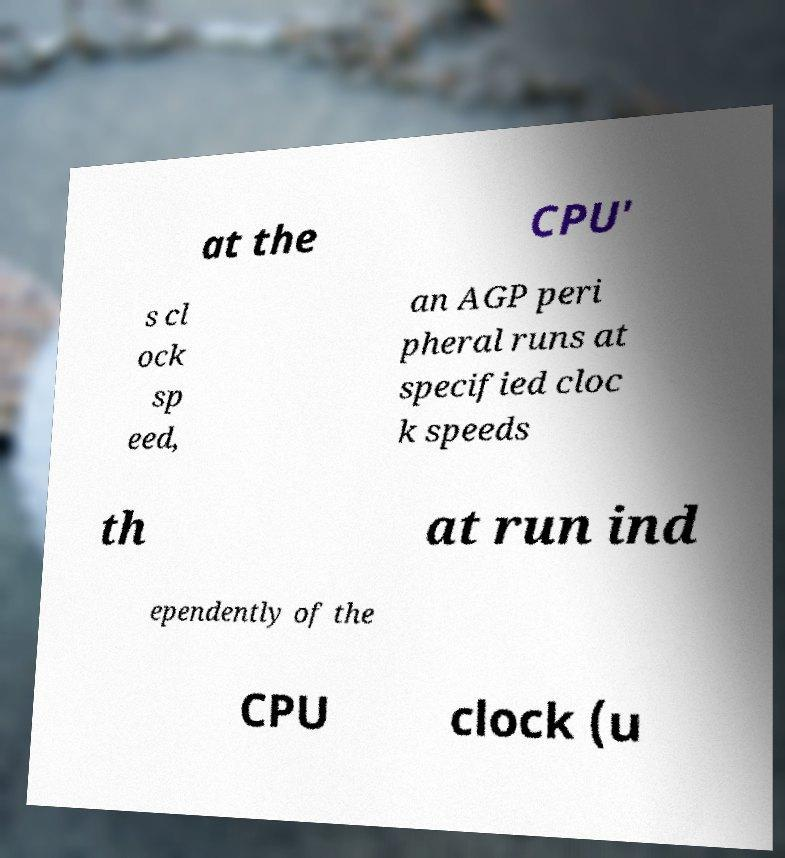I need the written content from this picture converted into text. Can you do that? at the CPU' s cl ock sp eed, an AGP peri pheral runs at specified cloc k speeds th at run ind ependently of the CPU clock (u 